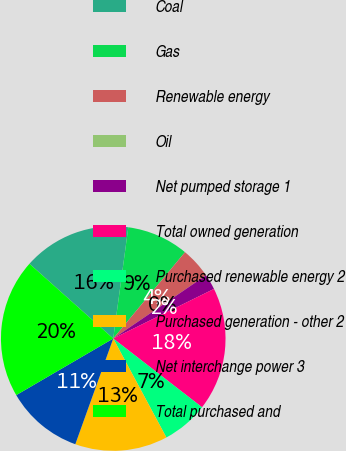Convert chart to OTSL. <chart><loc_0><loc_0><loc_500><loc_500><pie_chart><fcel>Coal<fcel>Gas<fcel>Renewable energy<fcel>Oil<fcel>Net pumped storage 1<fcel>Total owned generation<fcel>Purchased renewable energy 2<fcel>Purchased generation - other 2<fcel>Net interchange power 3<fcel>Total purchased and<nl><fcel>15.55%<fcel>8.89%<fcel>4.45%<fcel>0.0%<fcel>2.23%<fcel>17.77%<fcel>6.67%<fcel>13.33%<fcel>11.11%<fcel>20.0%<nl></chart> 